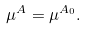Convert formula to latex. <formula><loc_0><loc_0><loc_500><loc_500>\mu ^ { A } = \mu ^ { A _ { 0 } } .</formula> 